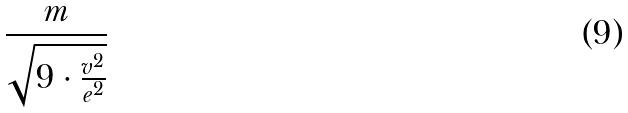<formula> <loc_0><loc_0><loc_500><loc_500>\frac { m } { \sqrt { 9 \cdot \frac { v ^ { 2 } } { e ^ { 2 } } } }</formula> 